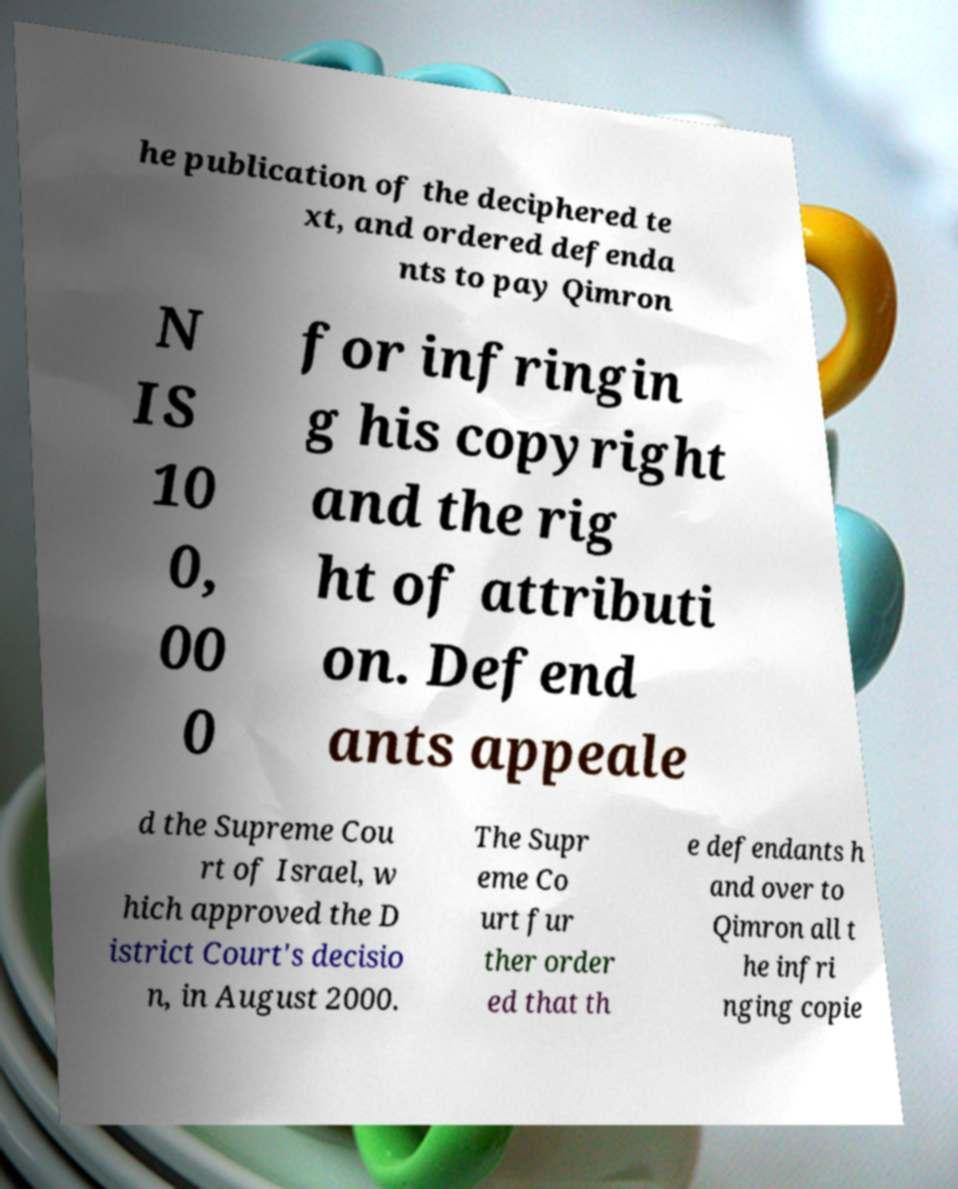Can you read and provide the text displayed in the image?This photo seems to have some interesting text. Can you extract and type it out for me? he publication of the deciphered te xt, and ordered defenda nts to pay Qimron N IS 10 0, 00 0 for infringin g his copyright and the rig ht of attributi on. Defend ants appeale d the Supreme Cou rt of Israel, w hich approved the D istrict Court's decisio n, in August 2000. The Supr eme Co urt fur ther order ed that th e defendants h and over to Qimron all t he infri nging copie 